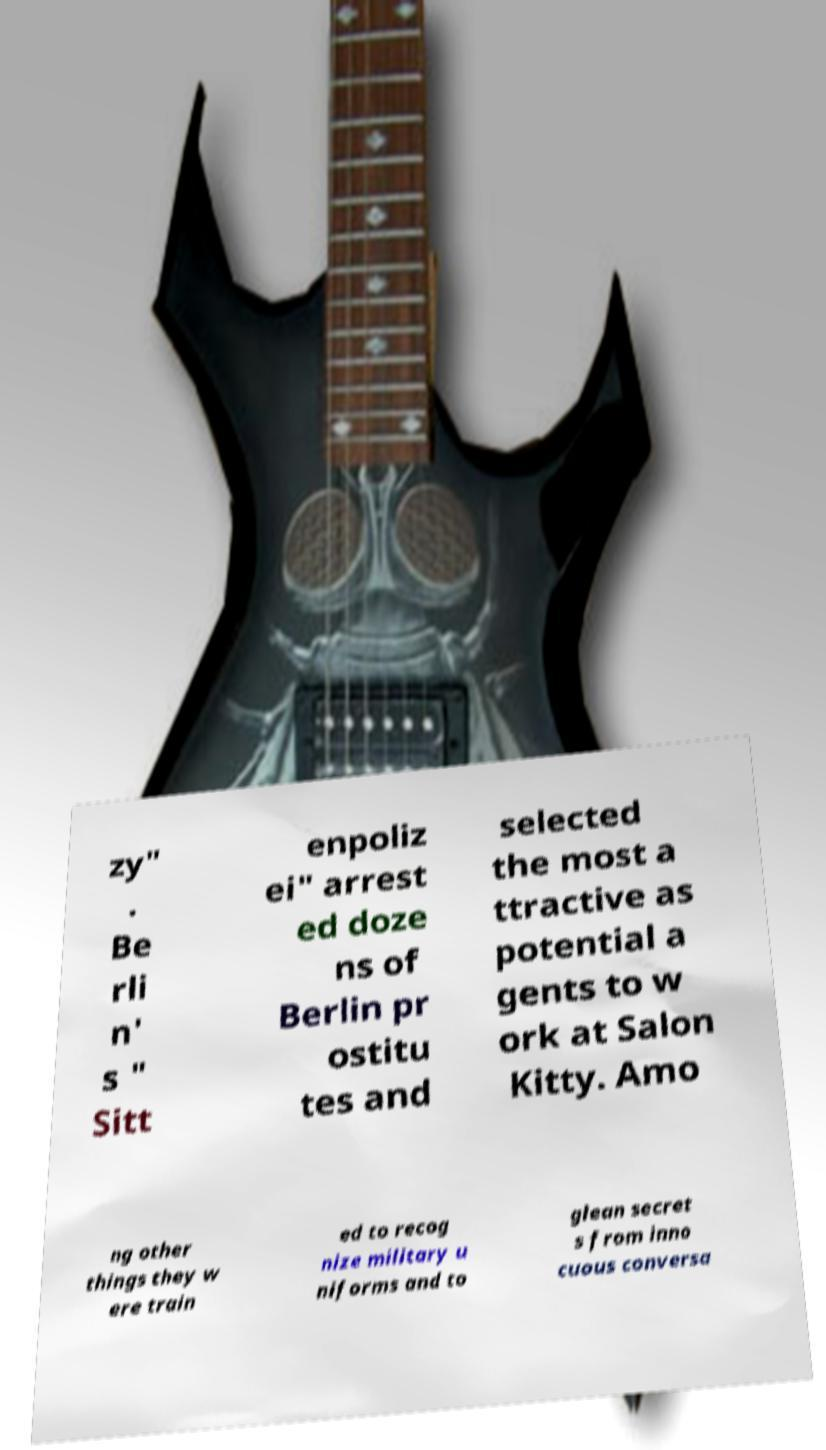Could you assist in decoding the text presented in this image and type it out clearly? zy" . Be rli n' s " Sitt enpoliz ei" arrest ed doze ns of Berlin pr ostitu tes and selected the most a ttractive as potential a gents to w ork at Salon Kitty. Amo ng other things they w ere train ed to recog nize military u niforms and to glean secret s from inno cuous conversa 